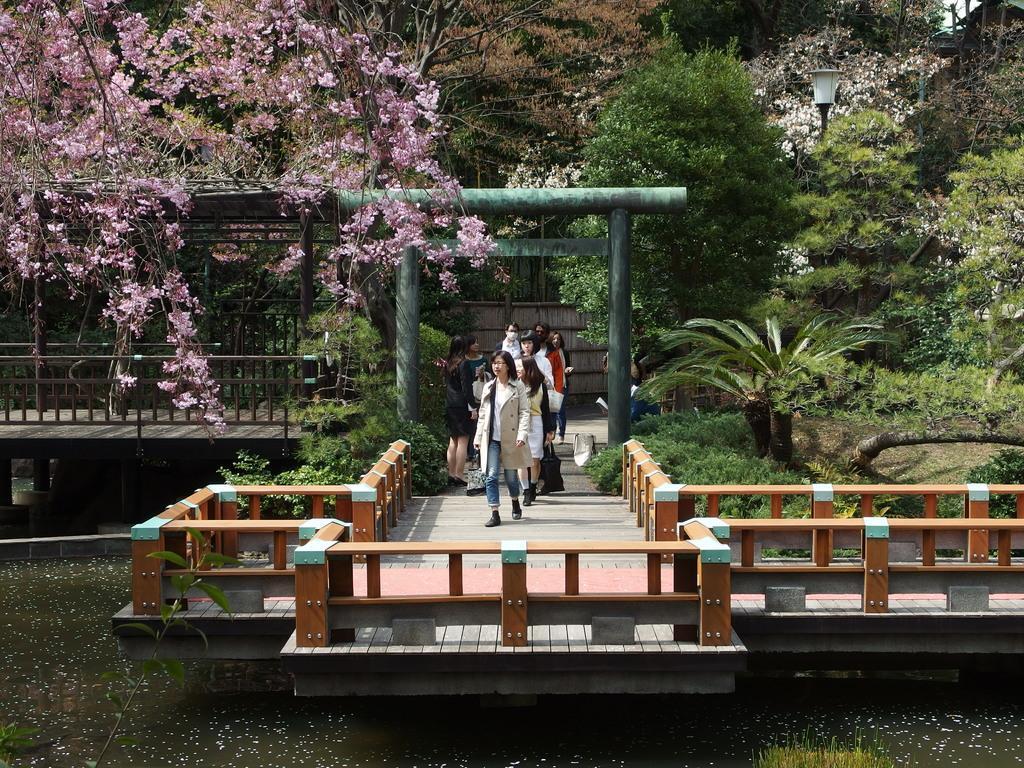How would you summarize this image in a sentence or two? In the center of the image, we can see people some are walking and some of them are standing and there is a bridge. In the background, there are trees along with flowers and we can see some plants and there is a light. At the bottom, there is water. 